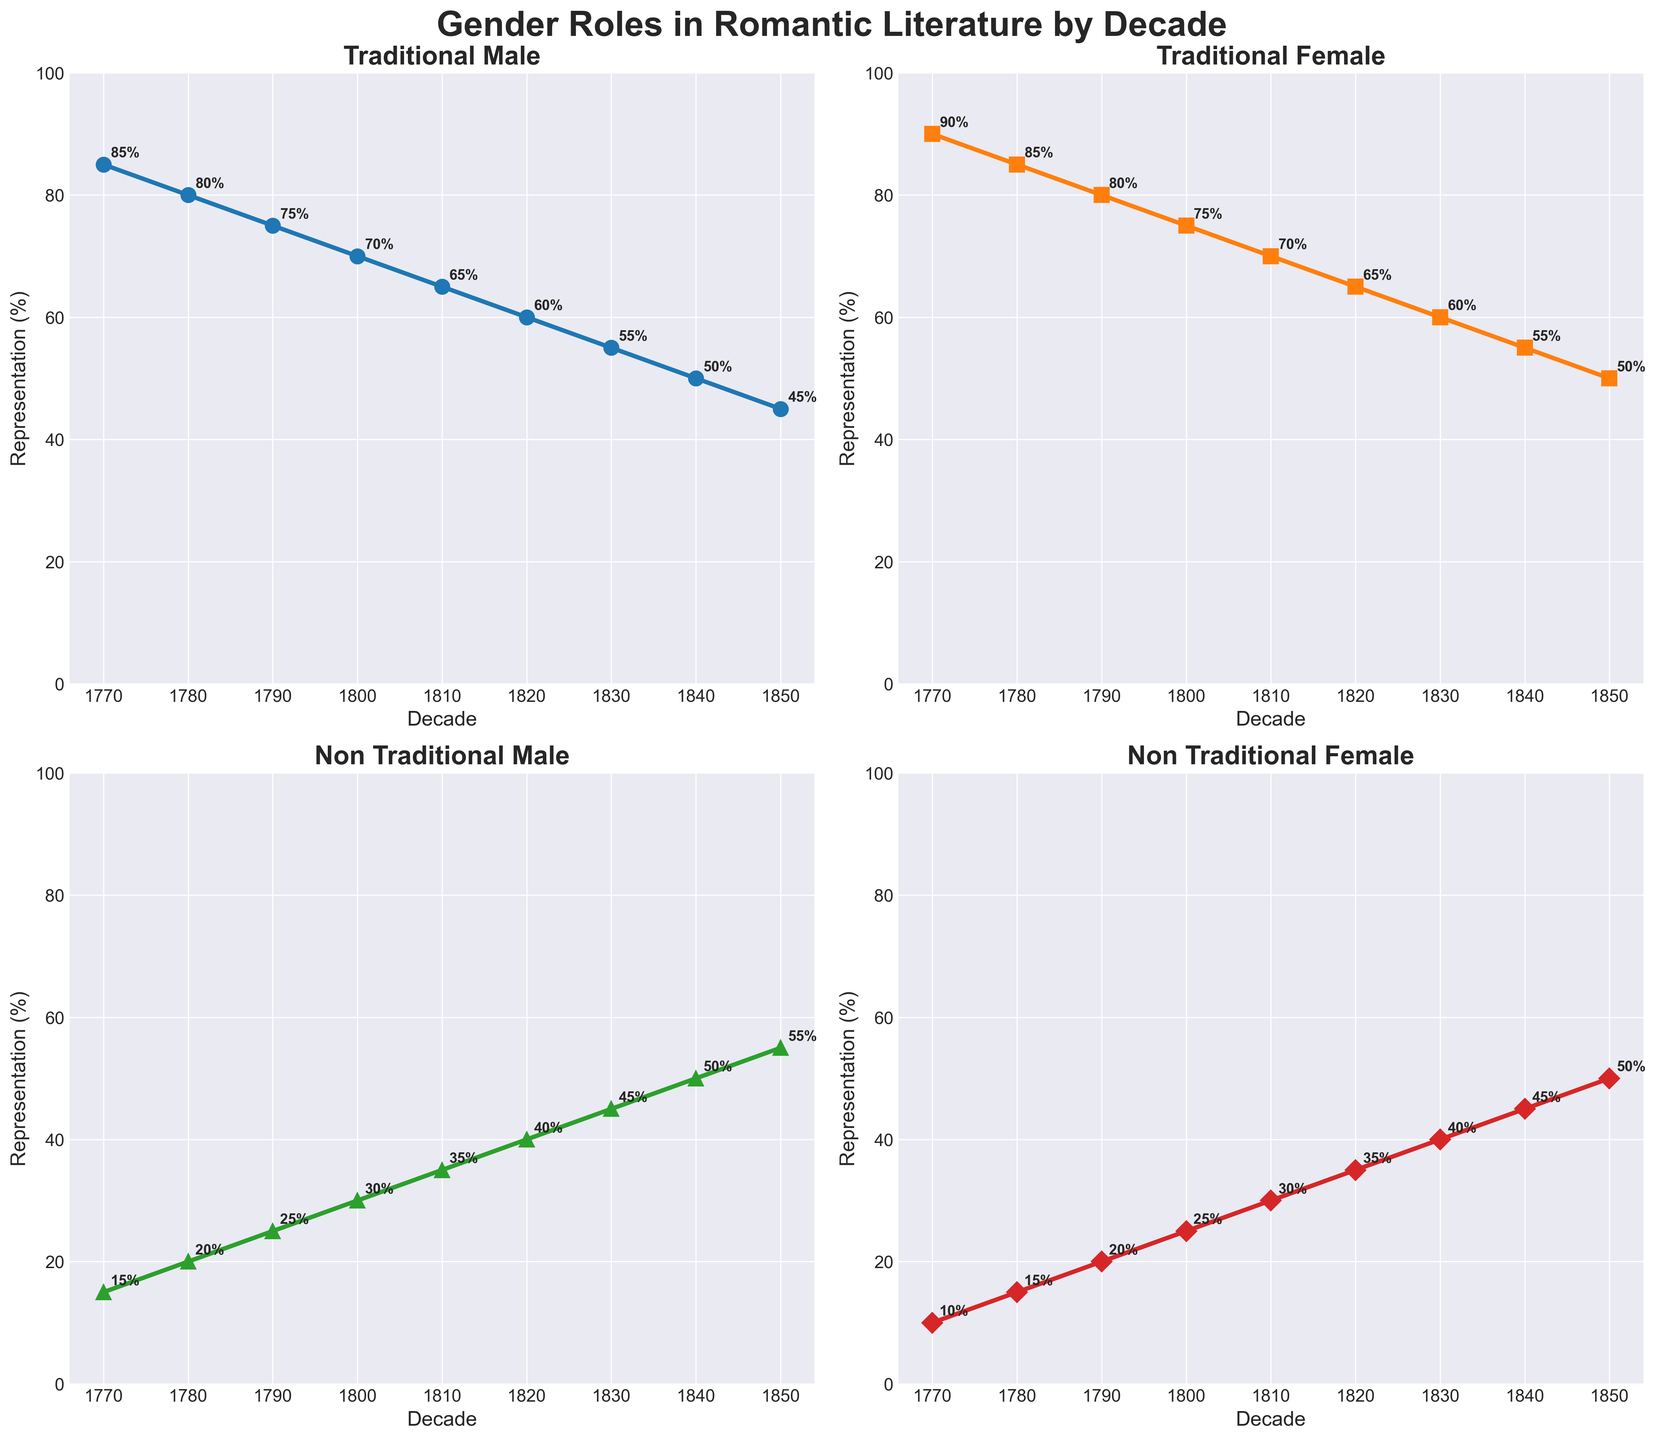Which decade shows the highest percentage of Traditional Male roles? Look at the "Traditional Male" subplot and identify the data point with the highest percentage, which occurs in the 1770s at 85%.
Answer: 1770 What is the trend for Non-Traditional Female roles from 1770 to 1850? Observe the "Non-Traditional Female" subplot and note the steady increase in percentage from 10% in 1770 to 50% in 1850.
Answer: Increasing By how much did the representation of Traditional Female roles decrease from 1770 to 1850? Check the "Traditional Female" subplot: In 1770 it was 90%, and in 1850 it is 50%. Calculate the difference: 90% - 50% = 40%.
Answer: 40% Compare the representation of Traditional Female roles to Non-Traditional Male roles in the 1840s. Which one is higher and by how much? In the 1840s, Traditional Female roles are at 55% and Non-Traditional Male roles are at 45%. The difference is 55% - 45% = 10%.
Answer: Traditional Female by 10% Over which decades do Non-Traditional Male roles show the greatest increase? Look at the "Non-Traditional Male" subplot and observe the data points. The most significant growth is from 1790 (25%) to 1850 (55%), showing an increase of 30%.
Answer: 1790 to 1850 What is the combined representation of Traditional Male and Female roles in 1810? Add the values for Traditional Male (65%) and Traditional Female (70%) roles in 1810: 65% + 70% = 135%.
Answer: 135% How does the representation of Traditional Male roles in the 1830s compare to the representation of Non-Traditional Female roles in the same decade? In the 1830s, Traditional Male roles are at 55%, and Non-Traditional Female roles are at 40%.
Answer: Traditional Male roles are 15% higher Which gender role experienced the smallest change in representation between 1770 and 1850? Calculate the change for each role: Traditional Male (85-45=40), Traditional Female (90-50=40), Non-Traditional Male (15-55=40), Non-Traditional Female (10-50=40). Every role changed by the same amount, which is 40%.
Answer: All roles experienced the same change What was the difference between Traditional Male and Traditional Female representations in 1790? For 1790, Traditional Male is 75% and Traditional Female is 80%. The difference is 80% - 75% = 5%.
Answer: 5% Which gender role subplots use markers with shapes different from circles? Identify the marker types used in the plots: Traditional Male uses circles, while Traditional Female uses squares, Non-Traditional Male uses triangles, and Non-Traditional Female uses diamonds.
Answer: Traditional Female, Non-Traditional Male, Non-Traditional Female 